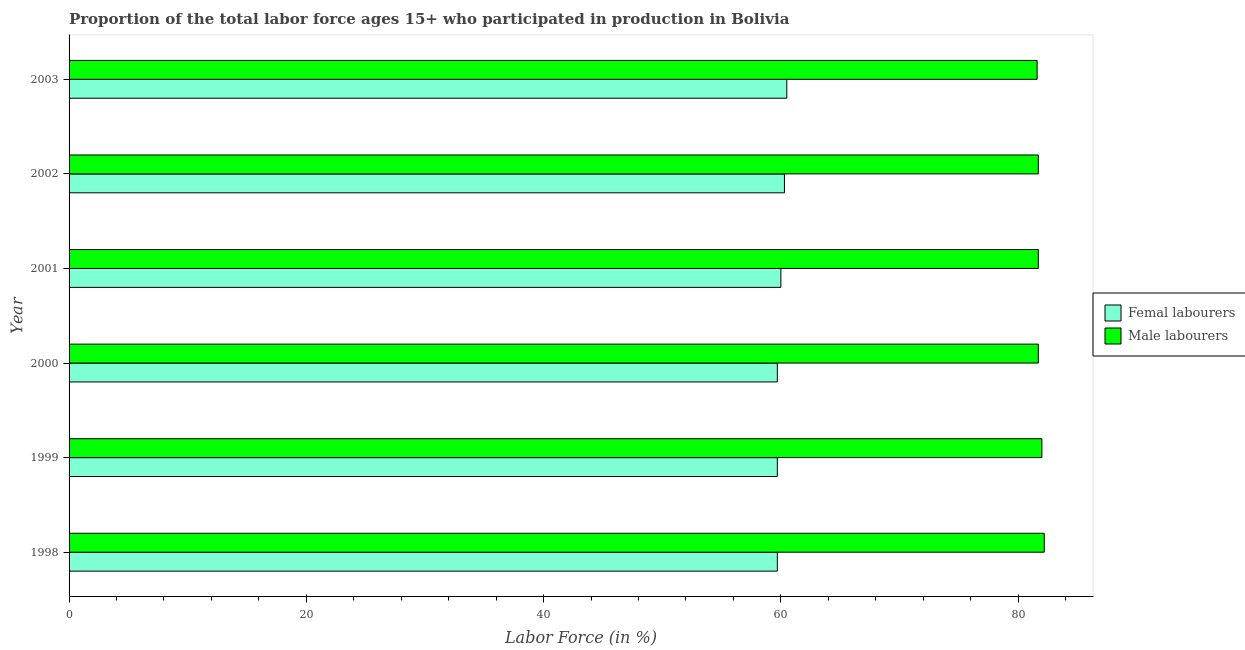How many groups of bars are there?
Ensure brevity in your answer.  6. How many bars are there on the 3rd tick from the bottom?
Provide a succinct answer. 2. What is the label of the 2nd group of bars from the top?
Make the answer very short. 2002. In how many cases, is the number of bars for a given year not equal to the number of legend labels?
Give a very brief answer. 0. What is the percentage of male labour force in 1998?
Ensure brevity in your answer.  82.2. Across all years, what is the maximum percentage of female labor force?
Offer a very short reply. 60.5. Across all years, what is the minimum percentage of female labor force?
Ensure brevity in your answer.  59.7. In which year was the percentage of male labour force minimum?
Offer a very short reply. 2003. What is the total percentage of female labor force in the graph?
Make the answer very short. 359.9. What is the difference between the percentage of male labour force in 1999 and the percentage of female labor force in 2002?
Provide a short and direct response. 21.7. What is the average percentage of male labour force per year?
Give a very brief answer. 81.82. What is the difference between the highest and the second highest percentage of female labor force?
Your answer should be very brief. 0.2. In how many years, is the percentage of female labor force greater than the average percentage of female labor force taken over all years?
Keep it short and to the point. 3. Is the sum of the percentage of female labor force in 2001 and 2002 greater than the maximum percentage of male labour force across all years?
Make the answer very short. Yes. What does the 2nd bar from the top in 1998 represents?
Give a very brief answer. Femal labourers. What does the 2nd bar from the bottom in 2001 represents?
Make the answer very short. Male labourers. How many bars are there?
Your answer should be compact. 12. Are all the bars in the graph horizontal?
Ensure brevity in your answer.  Yes. How many years are there in the graph?
Give a very brief answer. 6. What is the difference between two consecutive major ticks on the X-axis?
Your answer should be very brief. 20. Does the graph contain grids?
Make the answer very short. No. Where does the legend appear in the graph?
Offer a terse response. Center right. How many legend labels are there?
Keep it short and to the point. 2. How are the legend labels stacked?
Make the answer very short. Vertical. What is the title of the graph?
Provide a succinct answer. Proportion of the total labor force ages 15+ who participated in production in Bolivia. Does "Urban" appear as one of the legend labels in the graph?
Your answer should be very brief. No. What is the label or title of the X-axis?
Provide a short and direct response. Labor Force (in %). What is the Labor Force (in %) of Femal labourers in 1998?
Offer a very short reply. 59.7. What is the Labor Force (in %) in Male labourers in 1998?
Your answer should be very brief. 82.2. What is the Labor Force (in %) of Femal labourers in 1999?
Offer a terse response. 59.7. What is the Labor Force (in %) of Male labourers in 1999?
Your answer should be very brief. 82. What is the Labor Force (in %) of Femal labourers in 2000?
Offer a very short reply. 59.7. What is the Labor Force (in %) in Male labourers in 2000?
Your response must be concise. 81.7. What is the Labor Force (in %) of Male labourers in 2001?
Give a very brief answer. 81.7. What is the Labor Force (in %) of Femal labourers in 2002?
Provide a short and direct response. 60.3. What is the Labor Force (in %) in Male labourers in 2002?
Make the answer very short. 81.7. What is the Labor Force (in %) of Femal labourers in 2003?
Your answer should be compact. 60.5. What is the Labor Force (in %) in Male labourers in 2003?
Offer a very short reply. 81.6. Across all years, what is the maximum Labor Force (in %) in Femal labourers?
Give a very brief answer. 60.5. Across all years, what is the maximum Labor Force (in %) of Male labourers?
Your answer should be very brief. 82.2. Across all years, what is the minimum Labor Force (in %) of Femal labourers?
Your answer should be compact. 59.7. Across all years, what is the minimum Labor Force (in %) in Male labourers?
Keep it short and to the point. 81.6. What is the total Labor Force (in %) in Femal labourers in the graph?
Offer a terse response. 359.9. What is the total Labor Force (in %) in Male labourers in the graph?
Ensure brevity in your answer.  490.9. What is the difference between the Labor Force (in %) in Femal labourers in 1998 and that in 2001?
Provide a short and direct response. -0.3. What is the difference between the Labor Force (in %) of Male labourers in 1998 and that in 2001?
Your answer should be very brief. 0.5. What is the difference between the Labor Force (in %) in Male labourers in 1998 and that in 2002?
Make the answer very short. 0.5. What is the difference between the Labor Force (in %) of Femal labourers in 1998 and that in 2003?
Provide a succinct answer. -0.8. What is the difference between the Labor Force (in %) of Male labourers in 1998 and that in 2003?
Provide a short and direct response. 0.6. What is the difference between the Labor Force (in %) in Male labourers in 1999 and that in 2000?
Provide a succinct answer. 0.3. What is the difference between the Labor Force (in %) in Femal labourers in 1999 and that in 2001?
Give a very brief answer. -0.3. What is the difference between the Labor Force (in %) of Male labourers in 1999 and that in 2001?
Your response must be concise. 0.3. What is the difference between the Labor Force (in %) in Femal labourers in 1999 and that in 2002?
Give a very brief answer. -0.6. What is the difference between the Labor Force (in %) of Male labourers in 1999 and that in 2003?
Offer a terse response. 0.4. What is the difference between the Labor Force (in %) of Femal labourers in 2000 and that in 2001?
Make the answer very short. -0.3. What is the difference between the Labor Force (in %) of Femal labourers in 2000 and that in 2002?
Ensure brevity in your answer.  -0.6. What is the difference between the Labor Force (in %) of Male labourers in 2000 and that in 2002?
Make the answer very short. 0. What is the difference between the Labor Force (in %) of Male labourers in 2001 and that in 2002?
Provide a short and direct response. 0. What is the difference between the Labor Force (in %) of Femal labourers in 2001 and that in 2003?
Offer a very short reply. -0.5. What is the difference between the Labor Force (in %) of Male labourers in 2001 and that in 2003?
Provide a short and direct response. 0.1. What is the difference between the Labor Force (in %) of Femal labourers in 2002 and that in 2003?
Provide a succinct answer. -0.2. What is the difference between the Labor Force (in %) in Femal labourers in 1998 and the Labor Force (in %) in Male labourers in 1999?
Your answer should be very brief. -22.3. What is the difference between the Labor Force (in %) of Femal labourers in 1998 and the Labor Force (in %) of Male labourers in 2001?
Give a very brief answer. -22. What is the difference between the Labor Force (in %) in Femal labourers in 1998 and the Labor Force (in %) in Male labourers in 2003?
Your response must be concise. -21.9. What is the difference between the Labor Force (in %) in Femal labourers in 1999 and the Labor Force (in %) in Male labourers in 2003?
Make the answer very short. -21.9. What is the difference between the Labor Force (in %) in Femal labourers in 2000 and the Labor Force (in %) in Male labourers in 2001?
Provide a short and direct response. -22. What is the difference between the Labor Force (in %) of Femal labourers in 2000 and the Labor Force (in %) of Male labourers in 2002?
Provide a short and direct response. -22. What is the difference between the Labor Force (in %) in Femal labourers in 2000 and the Labor Force (in %) in Male labourers in 2003?
Provide a short and direct response. -21.9. What is the difference between the Labor Force (in %) of Femal labourers in 2001 and the Labor Force (in %) of Male labourers in 2002?
Ensure brevity in your answer.  -21.7. What is the difference between the Labor Force (in %) of Femal labourers in 2001 and the Labor Force (in %) of Male labourers in 2003?
Offer a terse response. -21.6. What is the difference between the Labor Force (in %) of Femal labourers in 2002 and the Labor Force (in %) of Male labourers in 2003?
Your response must be concise. -21.3. What is the average Labor Force (in %) of Femal labourers per year?
Provide a short and direct response. 59.98. What is the average Labor Force (in %) of Male labourers per year?
Make the answer very short. 81.82. In the year 1998, what is the difference between the Labor Force (in %) of Femal labourers and Labor Force (in %) of Male labourers?
Make the answer very short. -22.5. In the year 1999, what is the difference between the Labor Force (in %) in Femal labourers and Labor Force (in %) in Male labourers?
Ensure brevity in your answer.  -22.3. In the year 2000, what is the difference between the Labor Force (in %) in Femal labourers and Labor Force (in %) in Male labourers?
Provide a short and direct response. -22. In the year 2001, what is the difference between the Labor Force (in %) of Femal labourers and Labor Force (in %) of Male labourers?
Give a very brief answer. -21.7. In the year 2002, what is the difference between the Labor Force (in %) of Femal labourers and Labor Force (in %) of Male labourers?
Your answer should be very brief. -21.4. In the year 2003, what is the difference between the Labor Force (in %) in Femal labourers and Labor Force (in %) in Male labourers?
Provide a succinct answer. -21.1. What is the ratio of the Labor Force (in %) in Male labourers in 1998 to that in 1999?
Provide a succinct answer. 1. What is the ratio of the Labor Force (in %) of Femal labourers in 1998 to that in 2001?
Keep it short and to the point. 0.99. What is the ratio of the Labor Force (in %) in Male labourers in 1998 to that in 2002?
Your response must be concise. 1.01. What is the ratio of the Labor Force (in %) of Femal labourers in 1998 to that in 2003?
Give a very brief answer. 0.99. What is the ratio of the Labor Force (in %) in Male labourers in 1998 to that in 2003?
Keep it short and to the point. 1.01. What is the ratio of the Labor Force (in %) of Male labourers in 1999 to that in 2000?
Your response must be concise. 1. What is the ratio of the Labor Force (in %) of Femal labourers in 1999 to that in 2002?
Offer a very short reply. 0.99. What is the ratio of the Labor Force (in %) in Male labourers in 2000 to that in 2001?
Your answer should be compact. 1. What is the ratio of the Labor Force (in %) in Male labourers in 2000 to that in 2002?
Offer a very short reply. 1. What is the ratio of the Labor Force (in %) of Femal labourers in 2000 to that in 2003?
Give a very brief answer. 0.99. What is the ratio of the Labor Force (in %) of Femal labourers in 2001 to that in 2002?
Provide a short and direct response. 0.99. What is the ratio of the Labor Force (in %) in Femal labourers in 2001 to that in 2003?
Make the answer very short. 0.99. What is the ratio of the Labor Force (in %) of Male labourers in 2002 to that in 2003?
Make the answer very short. 1. What is the difference between the highest and the second highest Labor Force (in %) of Male labourers?
Make the answer very short. 0.2. What is the difference between the highest and the lowest Labor Force (in %) in Male labourers?
Provide a succinct answer. 0.6. 